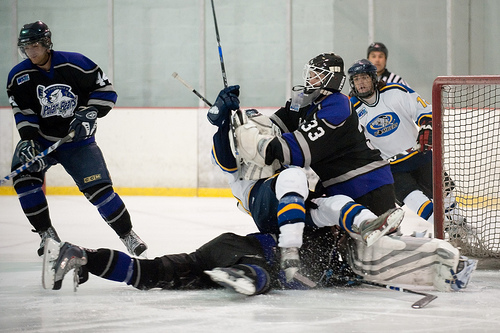<image>
Is the helmet on the hockey player? Yes. Looking at the image, I can see the helmet is positioned on top of the hockey player, with the hockey player providing support. Is there a man next to the ice? No. The man is not positioned next to the ice. They are located in different areas of the scene. 